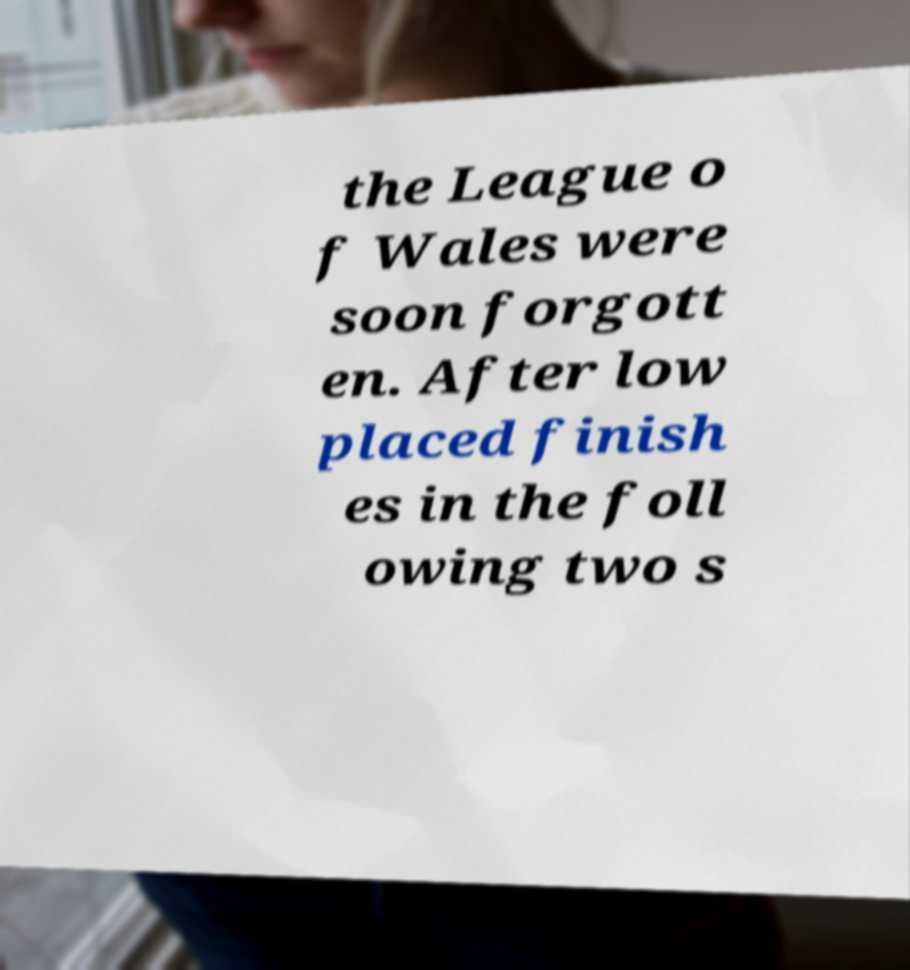What messages or text are displayed in this image? I need them in a readable, typed format. the League o f Wales were soon forgott en. After low placed finish es in the foll owing two s 